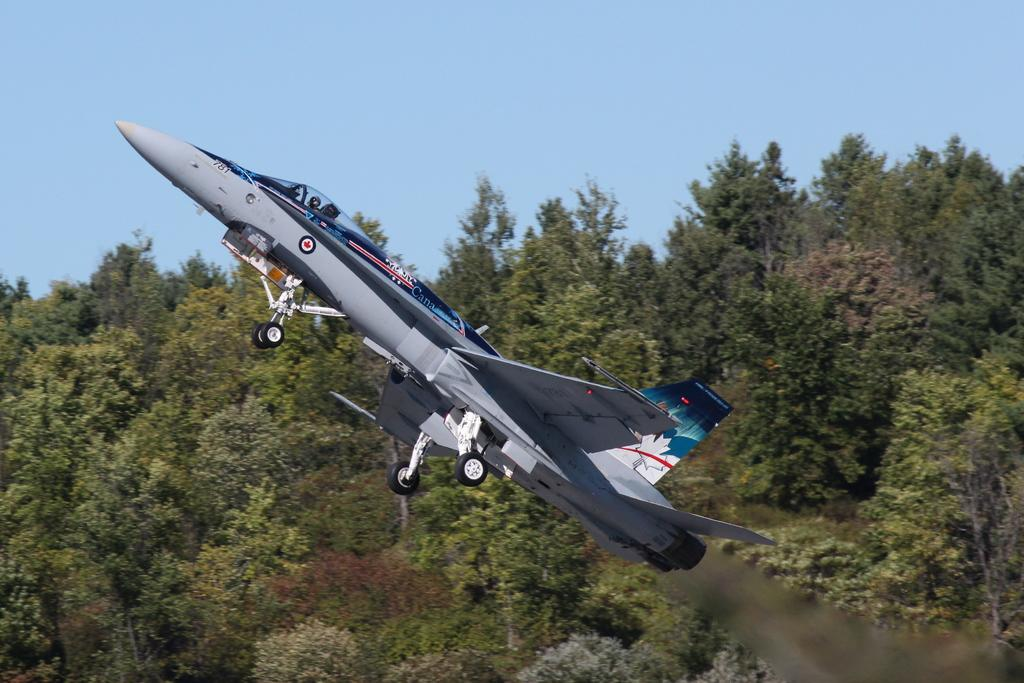What can be seen in the sky in the image? The sky is visible in the image. What type of natural elements are present in the image? Trees are present in the image. What man-made object is flying in the air in the image? An aircraft is flying in the air in the image. How many eyes can be seen on the mountain in the image? There is no mountain present in the image, and therefore no eyes can be seen on it. 